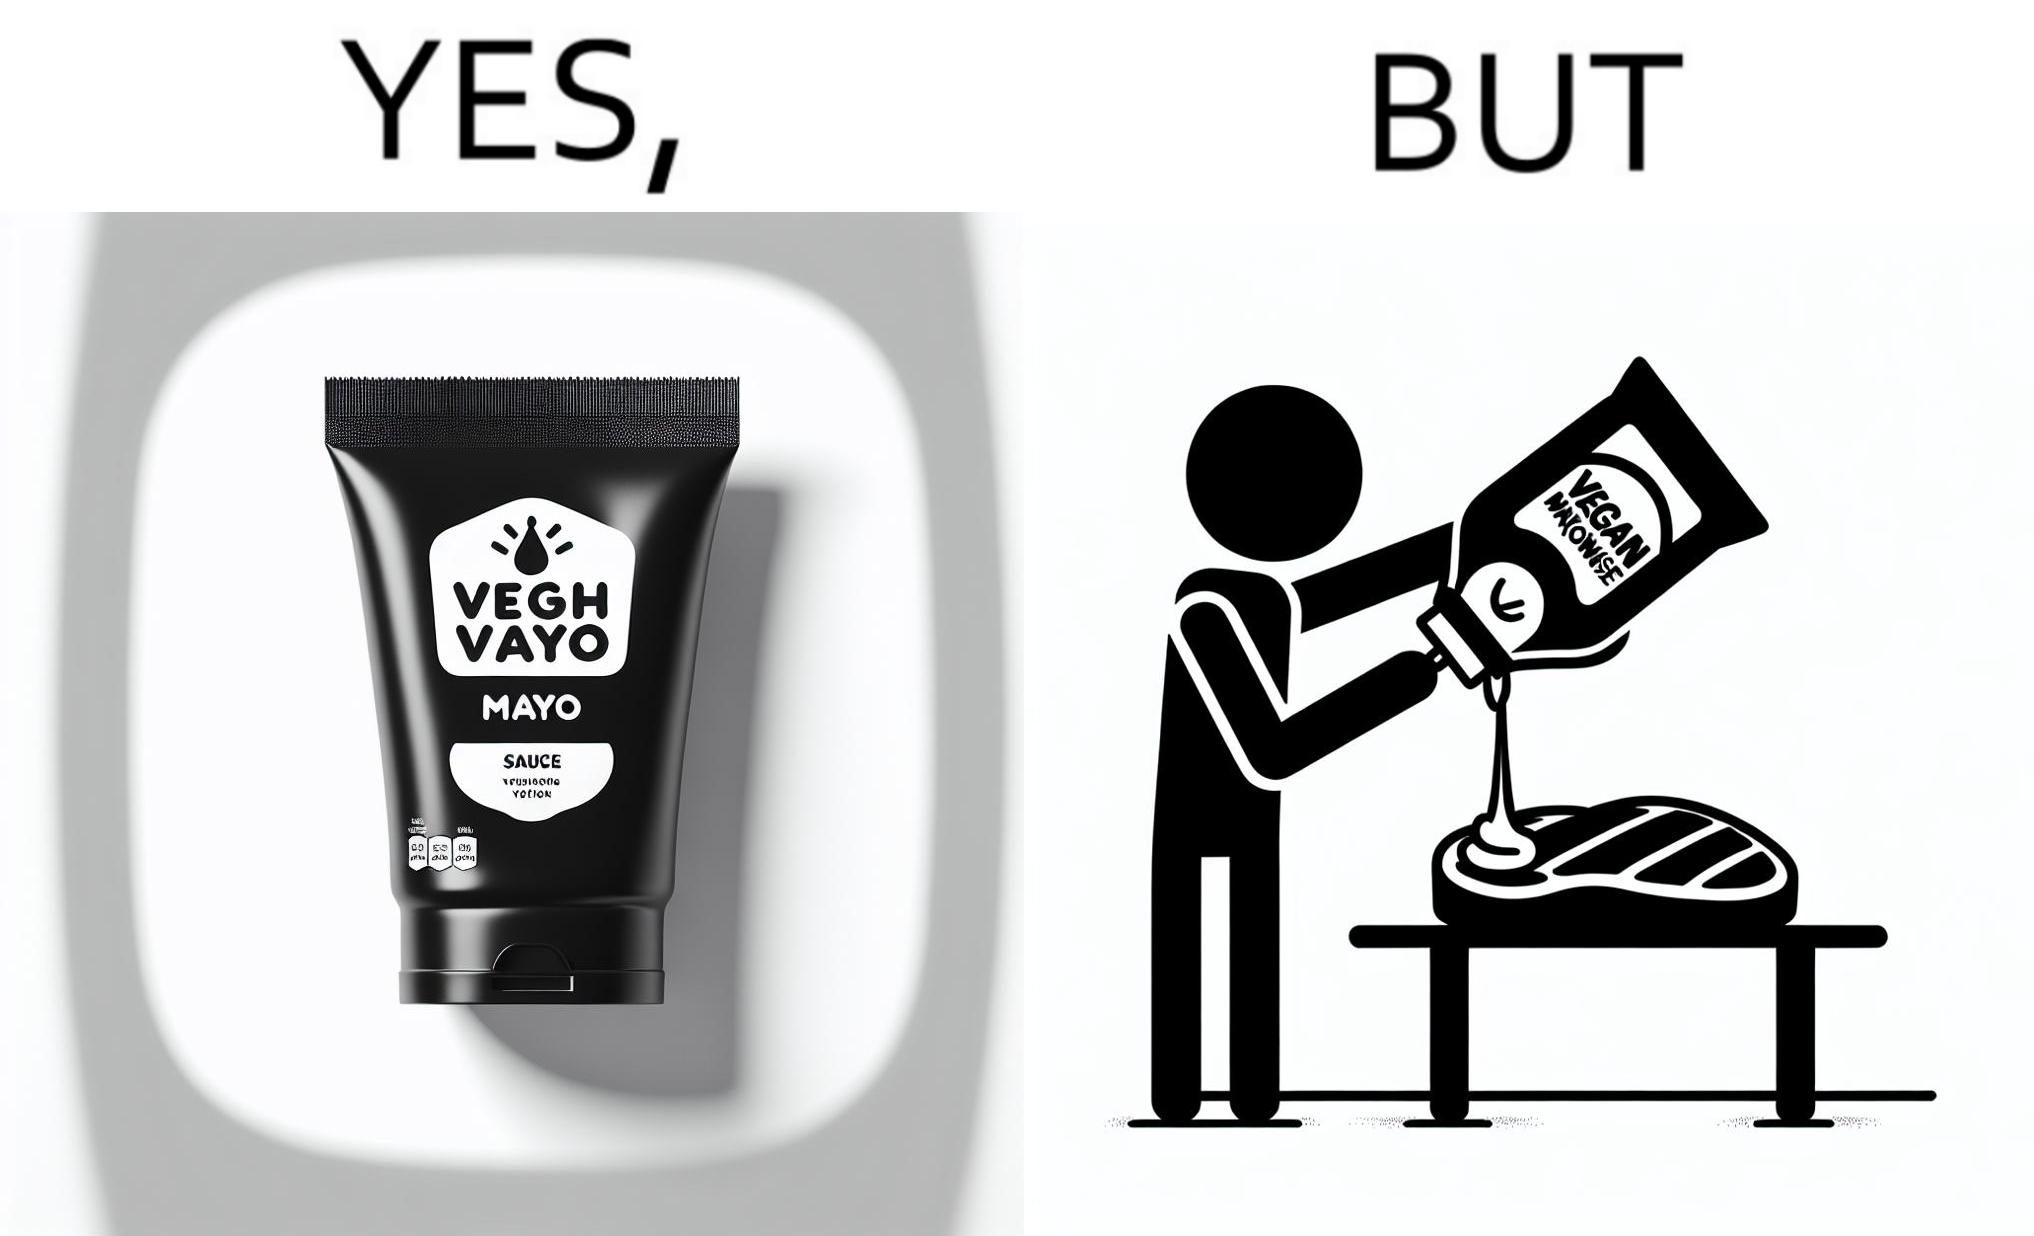Would you classify this image as satirical? Yes, this image is satirical. 